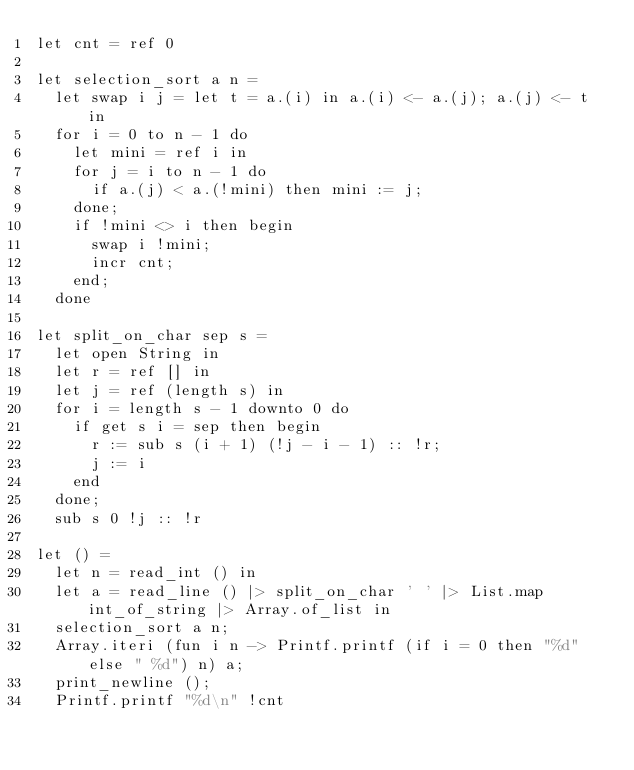<code> <loc_0><loc_0><loc_500><loc_500><_OCaml_>let cnt = ref 0

let selection_sort a n =
  let swap i j = let t = a.(i) in a.(i) <- a.(j); a.(j) <- t in
  for i = 0 to n - 1 do
    let mini = ref i in
    for j = i to n - 1 do
      if a.(j) < a.(!mini) then mini := j;
    done;
    if !mini <> i then begin
      swap i !mini;
      incr cnt;
    end;
  done

let split_on_char sep s =
  let open String in
  let r = ref [] in
  let j = ref (length s) in
  for i = length s - 1 downto 0 do
    if get s i = sep then begin
      r := sub s (i + 1) (!j - i - 1) :: !r;
      j := i
    end
  done;
  sub s 0 !j :: !r

let () =
  let n = read_int () in
  let a = read_line () |> split_on_char ' ' |> List.map int_of_string |> Array.of_list in
  selection_sort a n;
  Array.iteri (fun i n -> Printf.printf (if i = 0 then "%d" else " %d") n) a;
  print_newline ();
  Printf.printf "%d\n" !cnt</code> 